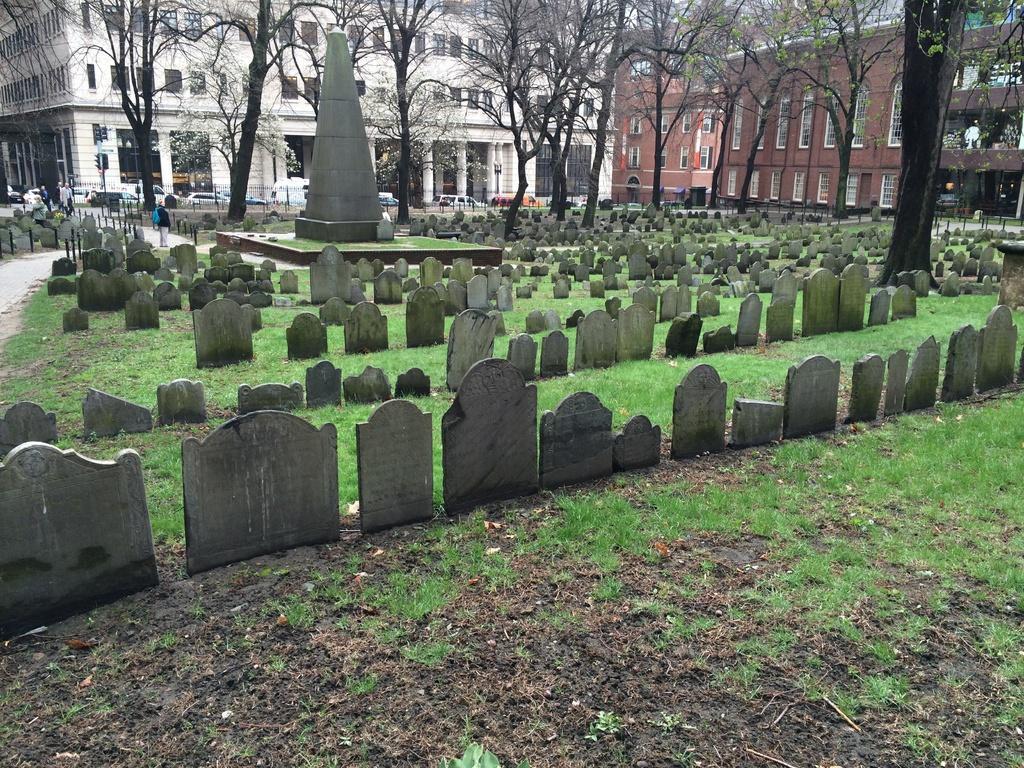In one or two sentences, can you explain what this image depicts? In this image in front there are headstones. In the center of the image there is a concrete structure. At the bottom of the image there is grass on the surface. There are people walking on the road. In the background of the image there are trees, buildings, cars. 